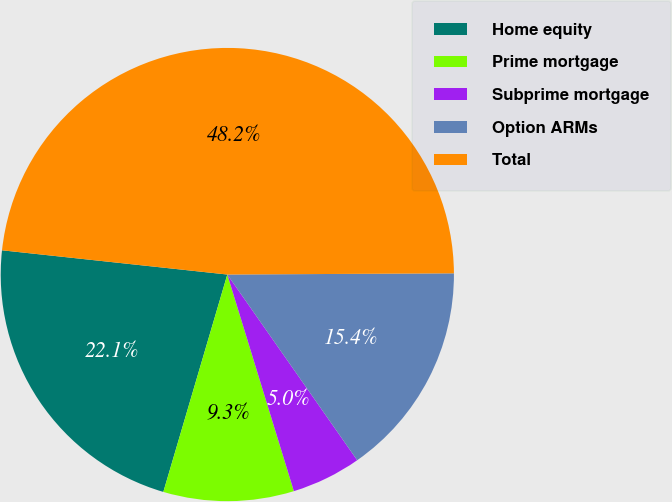Convert chart. <chart><loc_0><loc_0><loc_500><loc_500><pie_chart><fcel>Home equity<fcel>Prime mortgage<fcel>Subprime mortgage<fcel>Option ARMs<fcel>Total<nl><fcel>22.15%<fcel>9.3%<fcel>4.97%<fcel>15.37%<fcel>48.21%<nl></chart> 